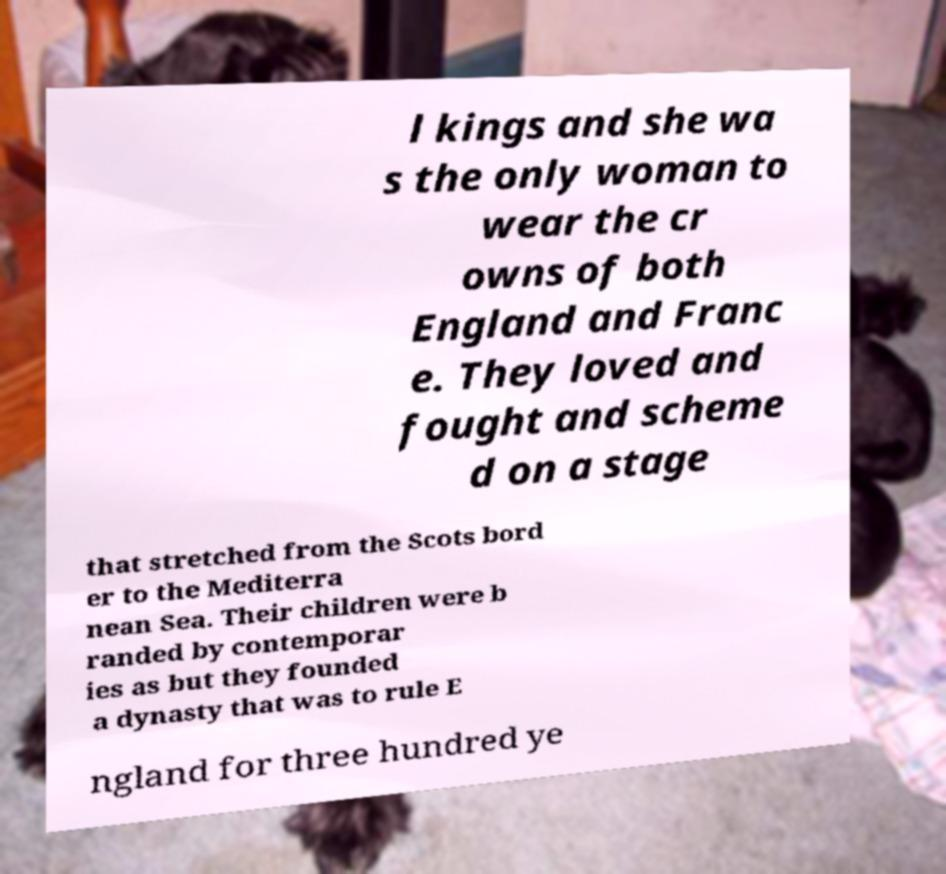There's text embedded in this image that I need extracted. Can you transcribe it verbatim? l kings and she wa s the only woman to wear the cr owns of both England and Franc e. They loved and fought and scheme d on a stage that stretched from the Scots bord er to the Mediterra nean Sea. Their children were b randed by contemporar ies as but they founded a dynasty that was to rule E ngland for three hundred ye 